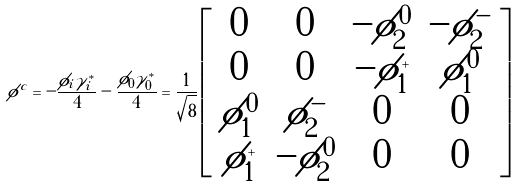<formula> <loc_0><loc_0><loc_500><loc_500>\phi ^ { c } = - \frac { \phi _ { i } \gamma ^ { * } _ { i } } { 4 } - \frac { \phi _ { 0 } \tilde { \gamma } ^ { * } _ { 0 } } { 4 } = \frac { 1 } { \sqrt { 8 } } \left [ \begin{array} { c c c c } 0 & 0 & - \phi ^ { 0 } _ { 2 } & - \phi ^ { - } _ { 2 } \\ 0 & 0 & - \phi ^ { + } _ { 1 } & \phi ^ { 0 } _ { 1 } \\ \phi ^ { 0 } _ { 1 } & \phi ^ { - } _ { 2 } & 0 & 0 \\ \phi ^ { + } _ { 1 } & - \phi ^ { 0 } _ { 2 } & 0 & 0 \\ \end{array} \right ]</formula> 